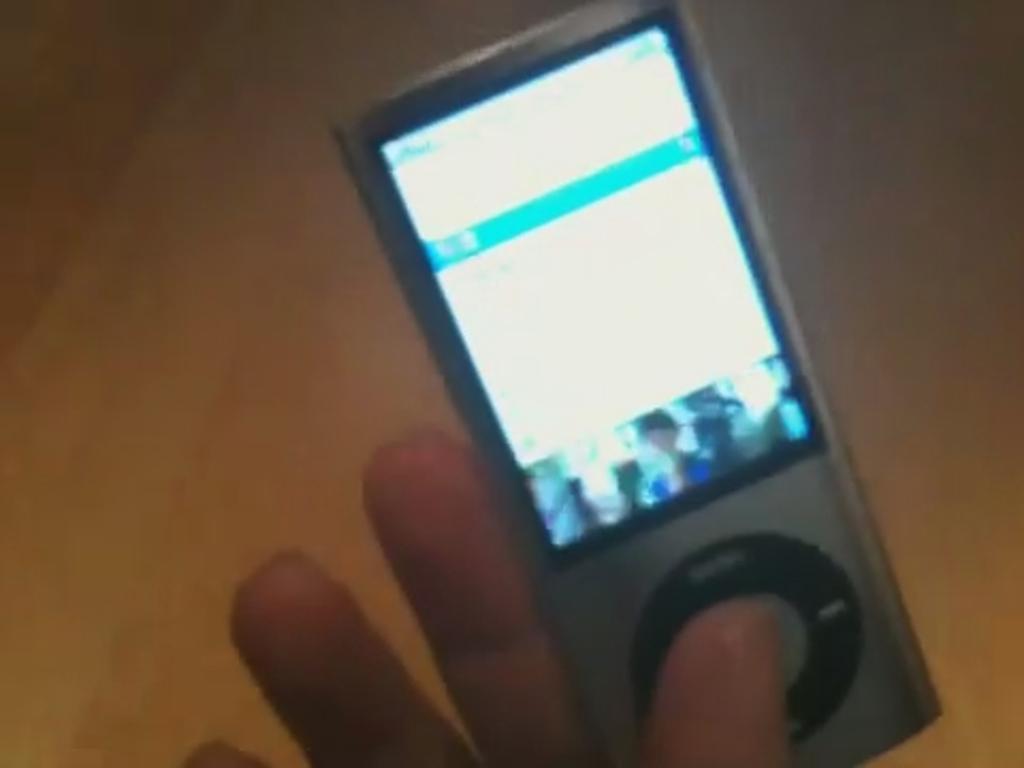In one or two sentences, can you explain what this image depicts? In this picture we can see a person hand and a device. 